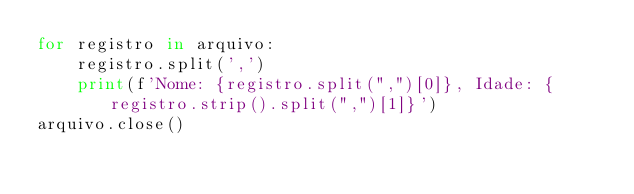Convert code to text. <code><loc_0><loc_0><loc_500><loc_500><_Python_>for registro in arquivo:
    registro.split(',')
    print(f'Nome: {registro.split(",")[0]}, Idade: {registro.strip().split(",")[1]}')
arquivo.close()</code> 